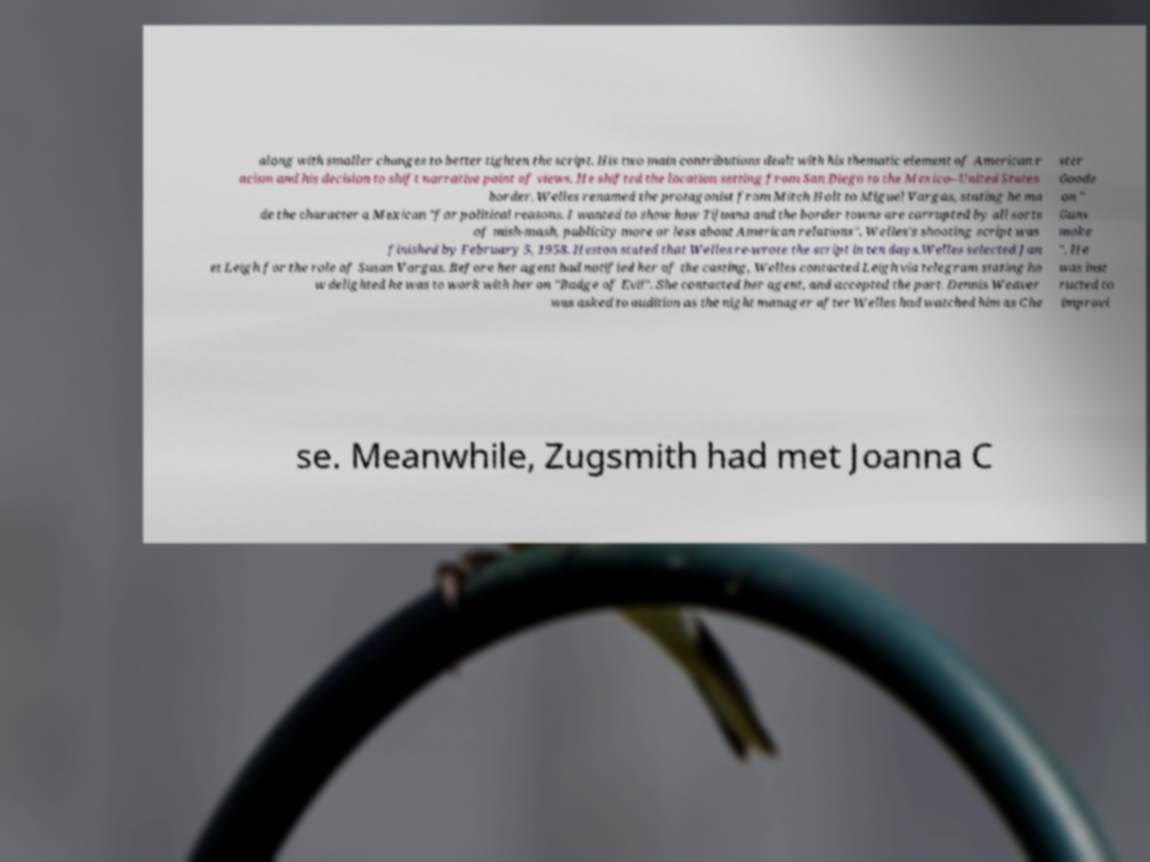For documentation purposes, I need the text within this image transcribed. Could you provide that? along with smaller changes to better tighten the script. His two main contributions dealt with his thematic element of American r acism and his decision to shift narrative point of views. He shifted the location setting from San Diego to the Mexico–United States border. Welles renamed the protagonist from Mitch Holt to Miguel Vargas, stating he ma de the character a Mexican "for political reasons. I wanted to show how Tijuana and the border towns are corrupted by all sorts of mish-mash, publicity more or less about American relations". Welles's shooting script was finished by February 5, 1958. Heston stated that Welles re-wrote the script in ten days.Welles selected Jan et Leigh for the role of Susan Vargas. Before her agent had notified her of the casting, Welles contacted Leigh via telegram stating ho w delighted he was to work with her on "Badge of Evil". She contacted her agent, and accepted the part. Dennis Weaver was asked to audition as the night manager after Welles had watched him as Che ster Goode on " Guns moke ". He was inst ructed to improvi se. Meanwhile, Zugsmith had met Joanna C 